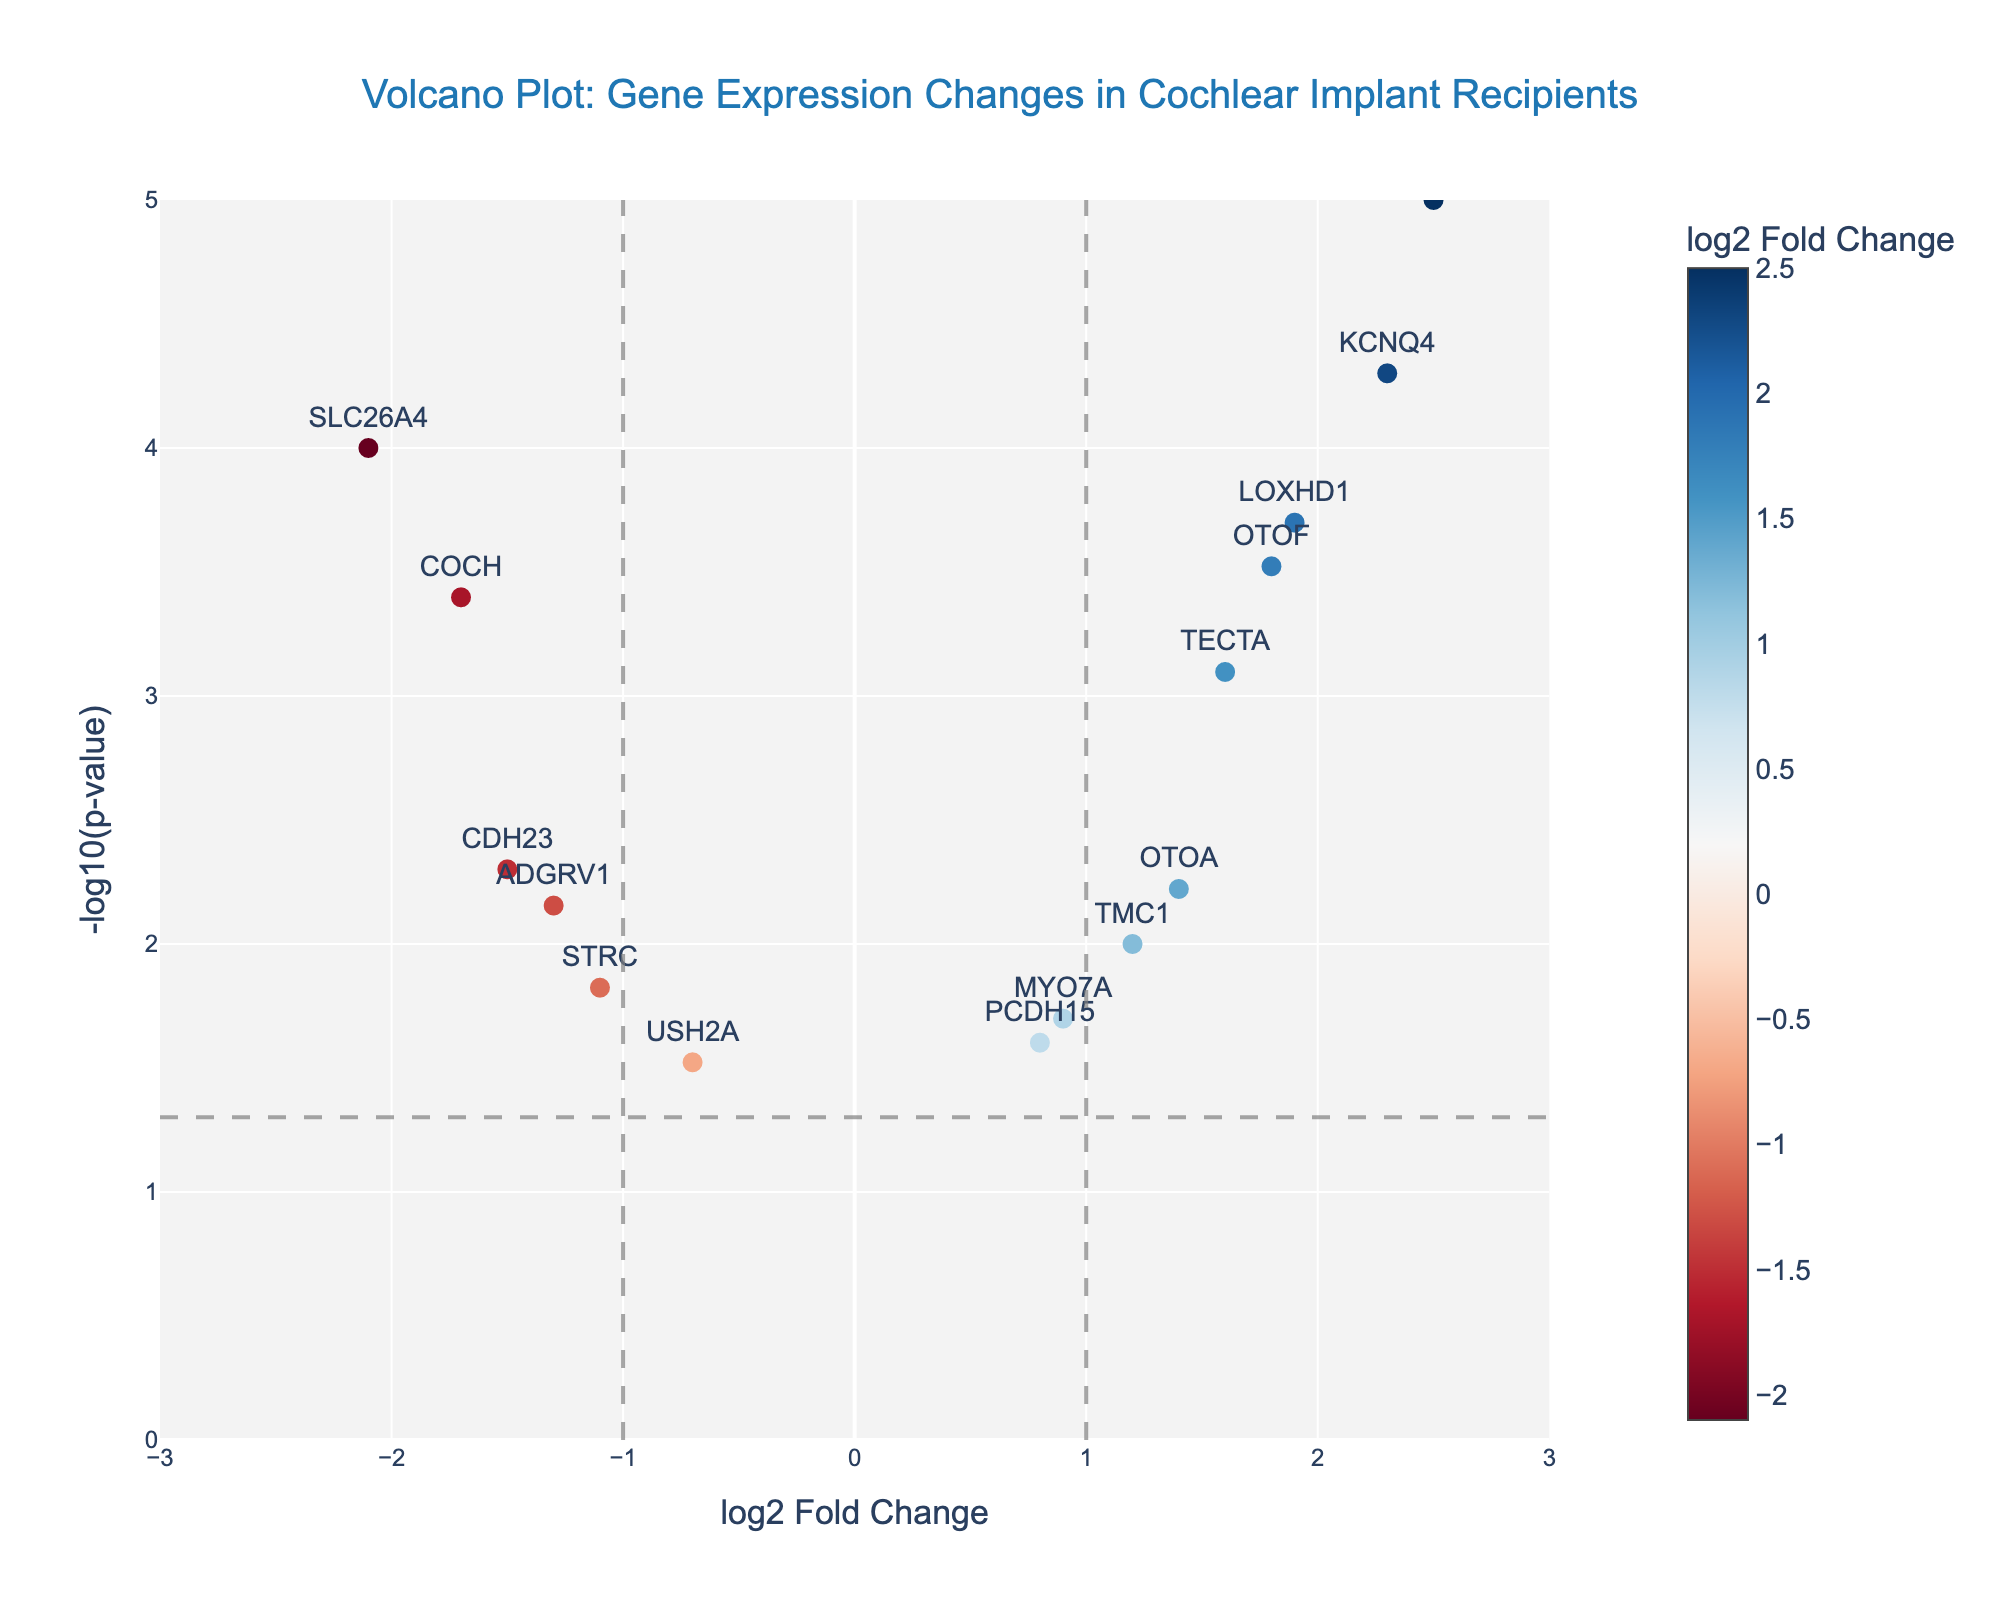How many data points are shown in the plot? The plot shows data points corresponding to each gene in the dataset. We see genes such as SLC26A4, OTOF, MYO7A, etc. listed on the plot. By counting these genes, we find there are 15 data points.
Answer: 15 Which gene shows the highest log2 Fold Change value? The x-axis of the figure represents log2 Fold Change values. By looking at the data points on the rightmost part of the plot, we identify the gene labeled farthest as KCNQ4, corresponding to a log2 Fold Change of 2.5.
Answer: GJB2 Which gene has the most significant p-value? The y-axis represents -log10(p-value). The higher the point, the smaller the p-value. The topmost point on the plot corresponds to the gene GJB2 with a p-value of 0.00001.
Answer: GJB2 Which gene shows the most significant negative log2 Fold Change? Negative log2 Fold Change values are on the left side of the y-axis. Check the leftmost point that is the lowest in its y-axis value (most negative log2 Fold Change), which is SLC26A4 with -2.1.
Answer: SLC26A4 How many genes have a log2 Fold Change value greater than 1? Look at the data points on the right side of the x=1 threshold line. The genes there are OTOF, KCNQ4, TMC1, LOXHD1, OTOA, TECTA, GJB2. Counting these, there are 7 genes.
Answer: 7 Is there any gene that has a p-value greater than 0.05? The horizontal dashed line represents the significance threshold of p=0.05. Data points below this line have a p-value greater than 0.05. In this plot, no data points fall below the threshold.
Answer: No Which genes have a log2 Fold Change value between -1 and 1? Look at data points within -1 to 1 bounds on the x-axis. These genes are MYO7A, PCDH15, and USH2A.
Answer: MYO7A, PCDH15, USH2A How many genes are significantly upregulated? Significantly upregulated genes would have a log2 Fold Change >1 and p-value <0.05 (above the horizontal threshold line). This includes genes such as KCNQ4, TECTA, LOXHD1, OTOA, and GJB2. There are 5 genes.
Answer: 5 What is the log2 Fold Change value for gene CDH23? Locate the gene labeled CDH23 on the plot and check the x-coordinate value. CDH23 shows a log2 Fold Change of -1.5.
Answer: -1.5 